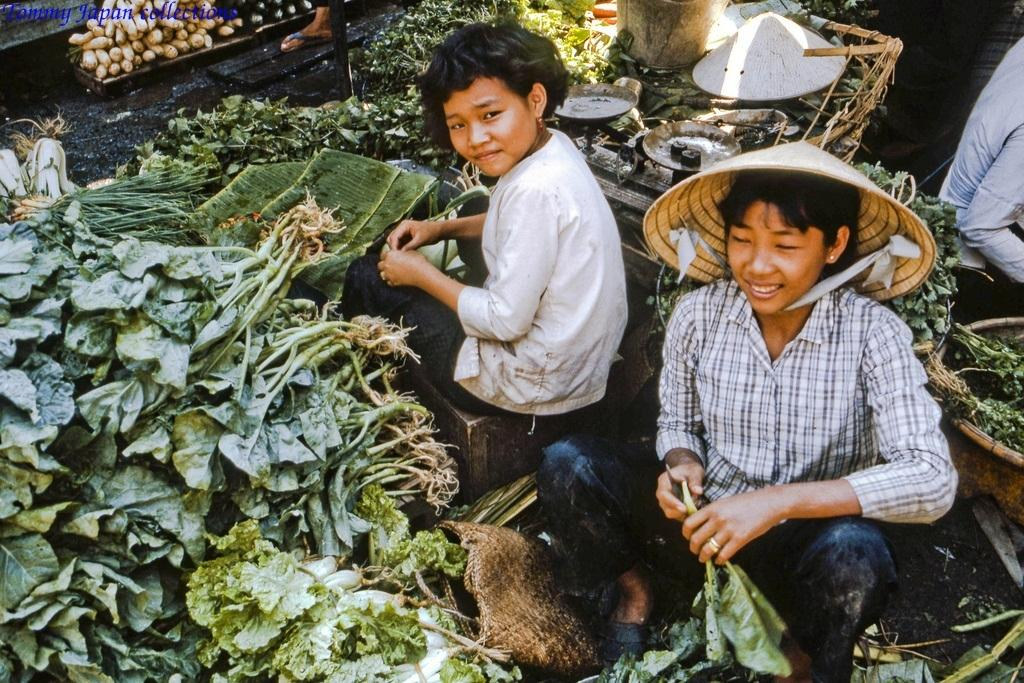How many people are present in the image? There are two people in the image. What are the people doing in the image? The people are selling leafy vegetables. What tool is used to weigh the vegetables in the image? There is a weighing machine in the image. Can you describe the person on the right side of the image? There is another person visible on the right side of the image. What type of tank is visible in the image? There is no tank present in the image. How many dolls are being sold by the people in the image? The people in the image are selling leafy vegetables, not dolls. 